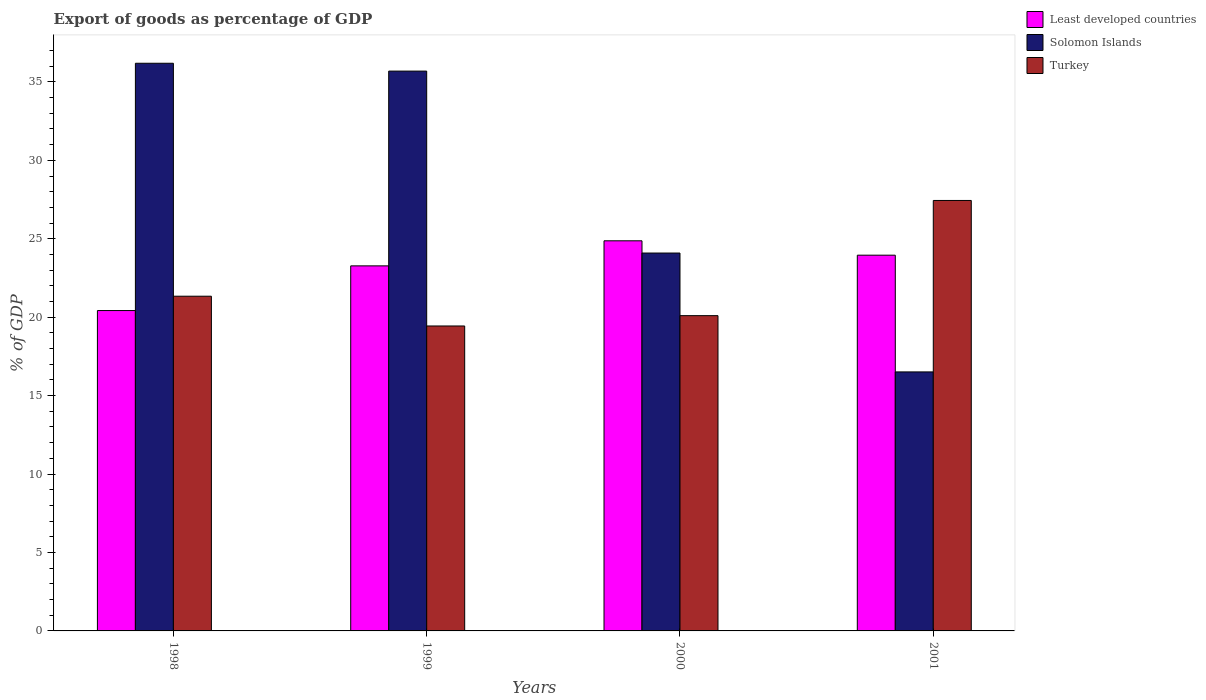How many different coloured bars are there?
Your answer should be compact. 3. Are the number of bars per tick equal to the number of legend labels?
Provide a short and direct response. Yes. Are the number of bars on each tick of the X-axis equal?
Provide a succinct answer. Yes. How many bars are there on the 4th tick from the left?
Keep it short and to the point. 3. What is the label of the 4th group of bars from the left?
Make the answer very short. 2001. What is the export of goods as percentage of GDP in Turkey in 2001?
Your answer should be very brief. 27.44. Across all years, what is the maximum export of goods as percentage of GDP in Turkey?
Your answer should be very brief. 27.44. Across all years, what is the minimum export of goods as percentage of GDP in Solomon Islands?
Ensure brevity in your answer.  16.51. In which year was the export of goods as percentage of GDP in Least developed countries maximum?
Your answer should be very brief. 2000. What is the total export of goods as percentage of GDP in Solomon Islands in the graph?
Provide a short and direct response. 112.48. What is the difference between the export of goods as percentage of GDP in Solomon Islands in 1998 and that in 1999?
Provide a succinct answer. 0.5. What is the difference between the export of goods as percentage of GDP in Least developed countries in 1998 and the export of goods as percentage of GDP in Turkey in 1999?
Provide a short and direct response. 0.98. What is the average export of goods as percentage of GDP in Least developed countries per year?
Provide a succinct answer. 23.13. In the year 2000, what is the difference between the export of goods as percentage of GDP in Solomon Islands and export of goods as percentage of GDP in Least developed countries?
Provide a succinct answer. -0.78. In how many years, is the export of goods as percentage of GDP in Least developed countries greater than 31 %?
Your answer should be compact. 0. What is the ratio of the export of goods as percentage of GDP in Least developed countries in 1998 to that in 2000?
Keep it short and to the point. 0.82. Is the export of goods as percentage of GDP in Turkey in 2000 less than that in 2001?
Ensure brevity in your answer.  Yes. What is the difference between the highest and the second highest export of goods as percentage of GDP in Least developed countries?
Offer a terse response. 0.92. What is the difference between the highest and the lowest export of goods as percentage of GDP in Turkey?
Give a very brief answer. 8. In how many years, is the export of goods as percentage of GDP in Turkey greater than the average export of goods as percentage of GDP in Turkey taken over all years?
Ensure brevity in your answer.  1. What does the 1st bar from the left in 2001 represents?
Keep it short and to the point. Least developed countries. What does the 2nd bar from the right in 2000 represents?
Make the answer very short. Solomon Islands. How many bars are there?
Provide a short and direct response. 12. Are all the bars in the graph horizontal?
Your answer should be very brief. No. Are the values on the major ticks of Y-axis written in scientific E-notation?
Your response must be concise. No. Does the graph contain any zero values?
Your answer should be very brief. No. Does the graph contain grids?
Your answer should be compact. No. Where does the legend appear in the graph?
Your answer should be compact. Top right. How many legend labels are there?
Keep it short and to the point. 3. How are the legend labels stacked?
Provide a short and direct response. Vertical. What is the title of the graph?
Provide a succinct answer. Export of goods as percentage of GDP. What is the label or title of the X-axis?
Offer a terse response. Years. What is the label or title of the Y-axis?
Provide a succinct answer. % of GDP. What is the % of GDP in Least developed countries in 1998?
Give a very brief answer. 20.42. What is the % of GDP in Solomon Islands in 1998?
Offer a very short reply. 36.19. What is the % of GDP in Turkey in 1998?
Your answer should be compact. 21.34. What is the % of GDP of Least developed countries in 1999?
Provide a short and direct response. 23.27. What is the % of GDP of Solomon Islands in 1999?
Your answer should be very brief. 35.69. What is the % of GDP of Turkey in 1999?
Provide a short and direct response. 19.44. What is the % of GDP of Least developed countries in 2000?
Provide a succinct answer. 24.87. What is the % of GDP of Solomon Islands in 2000?
Give a very brief answer. 24.09. What is the % of GDP of Turkey in 2000?
Give a very brief answer. 20.1. What is the % of GDP of Least developed countries in 2001?
Keep it short and to the point. 23.95. What is the % of GDP of Solomon Islands in 2001?
Give a very brief answer. 16.51. What is the % of GDP in Turkey in 2001?
Your response must be concise. 27.44. Across all years, what is the maximum % of GDP of Least developed countries?
Provide a succinct answer. 24.87. Across all years, what is the maximum % of GDP in Solomon Islands?
Ensure brevity in your answer.  36.19. Across all years, what is the maximum % of GDP of Turkey?
Your answer should be compact. 27.44. Across all years, what is the minimum % of GDP of Least developed countries?
Ensure brevity in your answer.  20.42. Across all years, what is the minimum % of GDP of Solomon Islands?
Your answer should be compact. 16.51. Across all years, what is the minimum % of GDP of Turkey?
Your response must be concise. 19.44. What is the total % of GDP in Least developed countries in the graph?
Your response must be concise. 92.52. What is the total % of GDP in Solomon Islands in the graph?
Your response must be concise. 112.48. What is the total % of GDP in Turkey in the graph?
Give a very brief answer. 88.32. What is the difference between the % of GDP in Least developed countries in 1998 and that in 1999?
Your answer should be compact. -2.85. What is the difference between the % of GDP in Solomon Islands in 1998 and that in 1999?
Your answer should be compact. 0.5. What is the difference between the % of GDP in Turkey in 1998 and that in 1999?
Ensure brevity in your answer.  1.9. What is the difference between the % of GDP of Least developed countries in 1998 and that in 2000?
Your answer should be compact. -4.45. What is the difference between the % of GDP in Solomon Islands in 1998 and that in 2000?
Your response must be concise. 12.1. What is the difference between the % of GDP of Turkey in 1998 and that in 2000?
Give a very brief answer. 1.24. What is the difference between the % of GDP in Least developed countries in 1998 and that in 2001?
Offer a very short reply. -3.53. What is the difference between the % of GDP of Solomon Islands in 1998 and that in 2001?
Your response must be concise. 19.68. What is the difference between the % of GDP in Turkey in 1998 and that in 2001?
Keep it short and to the point. -6.1. What is the difference between the % of GDP of Least developed countries in 1999 and that in 2000?
Make the answer very short. -1.6. What is the difference between the % of GDP of Solomon Islands in 1999 and that in 2000?
Make the answer very short. 11.6. What is the difference between the % of GDP in Turkey in 1999 and that in 2000?
Offer a very short reply. -0.66. What is the difference between the % of GDP in Least developed countries in 1999 and that in 2001?
Ensure brevity in your answer.  -0.68. What is the difference between the % of GDP in Solomon Islands in 1999 and that in 2001?
Keep it short and to the point. 19.18. What is the difference between the % of GDP of Turkey in 1999 and that in 2001?
Provide a short and direct response. -8. What is the difference between the % of GDP of Least developed countries in 2000 and that in 2001?
Your answer should be very brief. 0.92. What is the difference between the % of GDP in Solomon Islands in 2000 and that in 2001?
Make the answer very short. 7.58. What is the difference between the % of GDP in Turkey in 2000 and that in 2001?
Provide a succinct answer. -7.34. What is the difference between the % of GDP in Least developed countries in 1998 and the % of GDP in Solomon Islands in 1999?
Make the answer very short. -15.26. What is the difference between the % of GDP of Least developed countries in 1998 and the % of GDP of Turkey in 1999?
Your answer should be compact. 0.98. What is the difference between the % of GDP of Solomon Islands in 1998 and the % of GDP of Turkey in 1999?
Make the answer very short. 16.75. What is the difference between the % of GDP of Least developed countries in 1998 and the % of GDP of Solomon Islands in 2000?
Your response must be concise. -3.67. What is the difference between the % of GDP in Least developed countries in 1998 and the % of GDP in Turkey in 2000?
Offer a very short reply. 0.33. What is the difference between the % of GDP of Solomon Islands in 1998 and the % of GDP of Turkey in 2000?
Your answer should be compact. 16.09. What is the difference between the % of GDP of Least developed countries in 1998 and the % of GDP of Solomon Islands in 2001?
Keep it short and to the point. 3.91. What is the difference between the % of GDP of Least developed countries in 1998 and the % of GDP of Turkey in 2001?
Provide a succinct answer. -7.02. What is the difference between the % of GDP of Solomon Islands in 1998 and the % of GDP of Turkey in 2001?
Your answer should be very brief. 8.75. What is the difference between the % of GDP of Least developed countries in 1999 and the % of GDP of Solomon Islands in 2000?
Offer a terse response. -0.82. What is the difference between the % of GDP of Least developed countries in 1999 and the % of GDP of Turkey in 2000?
Your response must be concise. 3.17. What is the difference between the % of GDP of Solomon Islands in 1999 and the % of GDP of Turkey in 2000?
Your answer should be compact. 15.59. What is the difference between the % of GDP in Least developed countries in 1999 and the % of GDP in Solomon Islands in 2001?
Keep it short and to the point. 6.76. What is the difference between the % of GDP of Least developed countries in 1999 and the % of GDP of Turkey in 2001?
Ensure brevity in your answer.  -4.17. What is the difference between the % of GDP of Solomon Islands in 1999 and the % of GDP of Turkey in 2001?
Provide a succinct answer. 8.25. What is the difference between the % of GDP of Least developed countries in 2000 and the % of GDP of Solomon Islands in 2001?
Offer a terse response. 8.36. What is the difference between the % of GDP in Least developed countries in 2000 and the % of GDP in Turkey in 2001?
Give a very brief answer. -2.57. What is the difference between the % of GDP in Solomon Islands in 2000 and the % of GDP in Turkey in 2001?
Your answer should be compact. -3.35. What is the average % of GDP of Least developed countries per year?
Your answer should be very brief. 23.13. What is the average % of GDP of Solomon Islands per year?
Your answer should be compact. 28.12. What is the average % of GDP of Turkey per year?
Keep it short and to the point. 22.08. In the year 1998, what is the difference between the % of GDP in Least developed countries and % of GDP in Solomon Islands?
Offer a very short reply. -15.76. In the year 1998, what is the difference between the % of GDP of Least developed countries and % of GDP of Turkey?
Provide a short and direct response. -0.91. In the year 1998, what is the difference between the % of GDP in Solomon Islands and % of GDP in Turkey?
Ensure brevity in your answer.  14.85. In the year 1999, what is the difference between the % of GDP of Least developed countries and % of GDP of Solomon Islands?
Your response must be concise. -12.42. In the year 1999, what is the difference between the % of GDP of Least developed countries and % of GDP of Turkey?
Provide a succinct answer. 3.83. In the year 1999, what is the difference between the % of GDP in Solomon Islands and % of GDP in Turkey?
Offer a terse response. 16.25. In the year 2000, what is the difference between the % of GDP in Least developed countries and % of GDP in Solomon Islands?
Your answer should be very brief. 0.78. In the year 2000, what is the difference between the % of GDP in Least developed countries and % of GDP in Turkey?
Provide a succinct answer. 4.77. In the year 2000, what is the difference between the % of GDP of Solomon Islands and % of GDP of Turkey?
Offer a terse response. 3.99. In the year 2001, what is the difference between the % of GDP in Least developed countries and % of GDP in Solomon Islands?
Make the answer very short. 7.44. In the year 2001, what is the difference between the % of GDP in Least developed countries and % of GDP in Turkey?
Provide a succinct answer. -3.49. In the year 2001, what is the difference between the % of GDP of Solomon Islands and % of GDP of Turkey?
Ensure brevity in your answer.  -10.93. What is the ratio of the % of GDP of Least developed countries in 1998 to that in 1999?
Provide a succinct answer. 0.88. What is the ratio of the % of GDP in Solomon Islands in 1998 to that in 1999?
Your response must be concise. 1.01. What is the ratio of the % of GDP in Turkey in 1998 to that in 1999?
Make the answer very short. 1.1. What is the ratio of the % of GDP of Least developed countries in 1998 to that in 2000?
Offer a terse response. 0.82. What is the ratio of the % of GDP of Solomon Islands in 1998 to that in 2000?
Provide a succinct answer. 1.5. What is the ratio of the % of GDP in Turkey in 1998 to that in 2000?
Provide a short and direct response. 1.06. What is the ratio of the % of GDP in Least developed countries in 1998 to that in 2001?
Offer a terse response. 0.85. What is the ratio of the % of GDP in Solomon Islands in 1998 to that in 2001?
Offer a terse response. 2.19. What is the ratio of the % of GDP of Turkey in 1998 to that in 2001?
Provide a succinct answer. 0.78. What is the ratio of the % of GDP in Least developed countries in 1999 to that in 2000?
Ensure brevity in your answer.  0.94. What is the ratio of the % of GDP of Solomon Islands in 1999 to that in 2000?
Your response must be concise. 1.48. What is the ratio of the % of GDP in Turkey in 1999 to that in 2000?
Ensure brevity in your answer.  0.97. What is the ratio of the % of GDP in Least developed countries in 1999 to that in 2001?
Provide a succinct answer. 0.97. What is the ratio of the % of GDP in Solomon Islands in 1999 to that in 2001?
Your answer should be compact. 2.16. What is the ratio of the % of GDP in Turkey in 1999 to that in 2001?
Make the answer very short. 0.71. What is the ratio of the % of GDP in Least developed countries in 2000 to that in 2001?
Keep it short and to the point. 1.04. What is the ratio of the % of GDP in Solomon Islands in 2000 to that in 2001?
Make the answer very short. 1.46. What is the ratio of the % of GDP of Turkey in 2000 to that in 2001?
Offer a terse response. 0.73. What is the difference between the highest and the second highest % of GDP in Least developed countries?
Make the answer very short. 0.92. What is the difference between the highest and the second highest % of GDP in Solomon Islands?
Provide a short and direct response. 0.5. What is the difference between the highest and the second highest % of GDP in Turkey?
Offer a terse response. 6.1. What is the difference between the highest and the lowest % of GDP of Least developed countries?
Offer a terse response. 4.45. What is the difference between the highest and the lowest % of GDP of Solomon Islands?
Offer a terse response. 19.68. What is the difference between the highest and the lowest % of GDP of Turkey?
Provide a succinct answer. 8. 